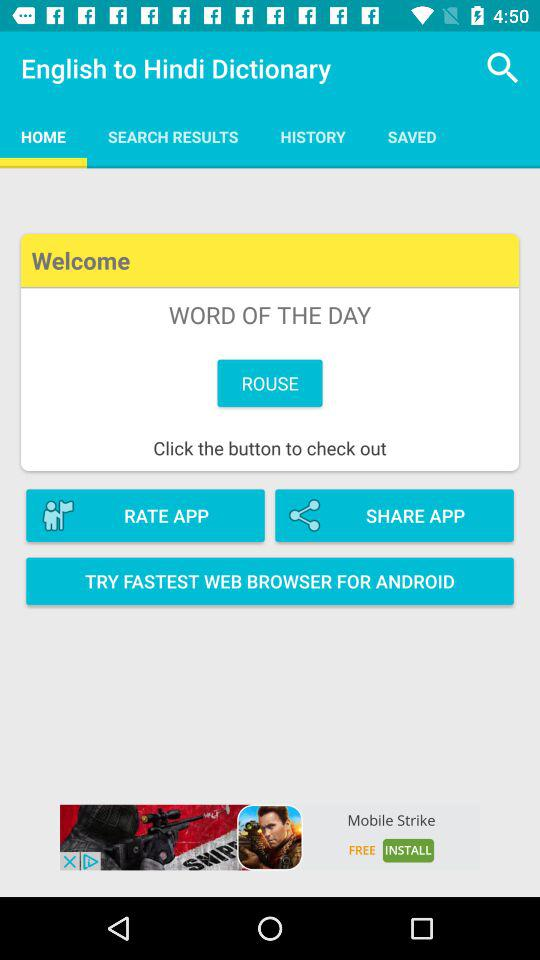When was the dictionary copyrighted?
When the provided information is insufficient, respond with <no answer>. <no answer> 